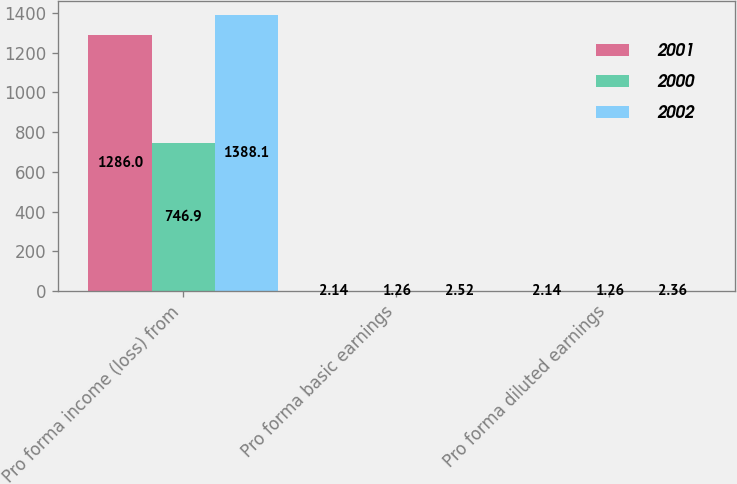Convert chart to OTSL. <chart><loc_0><loc_0><loc_500><loc_500><stacked_bar_chart><ecel><fcel>Pro forma income (loss) from<fcel>Pro forma basic earnings<fcel>Pro forma diluted earnings<nl><fcel>2001<fcel>1286<fcel>2.14<fcel>2.14<nl><fcel>2000<fcel>746.9<fcel>1.26<fcel>1.26<nl><fcel>2002<fcel>1388.1<fcel>2.52<fcel>2.36<nl></chart> 